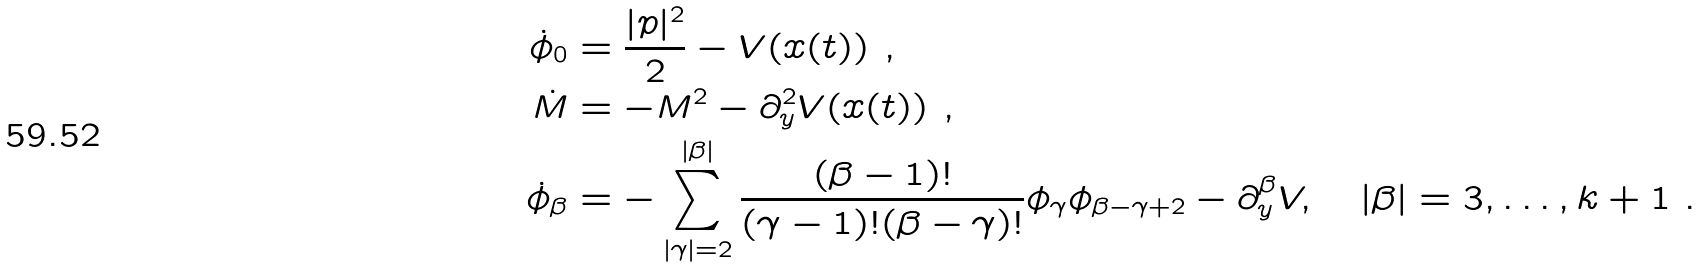Convert formula to latex. <formula><loc_0><loc_0><loc_500><loc_500>\dot { \phi } _ { 0 } & = \frac { | p | ^ { 2 } } { 2 } - V ( x ( t ) ) \ , \\ \dot { M } & = - M ^ { 2 } - \partial _ { y } ^ { 2 } V ( x ( t ) ) \ , \\ \dot { \phi } _ { \beta } & = - \sum _ { | \gamma | = 2 } ^ { | \beta | } \frac { ( \beta - 1 ) ! } { ( \gamma - 1 ) ! ( \beta - \gamma ) ! } \phi _ { \gamma } \phi _ { \beta - \gamma + 2 } - \partial ^ { \beta } _ { y } V , \quad | \beta | = 3 , \dots , k + 1 \ .</formula> 